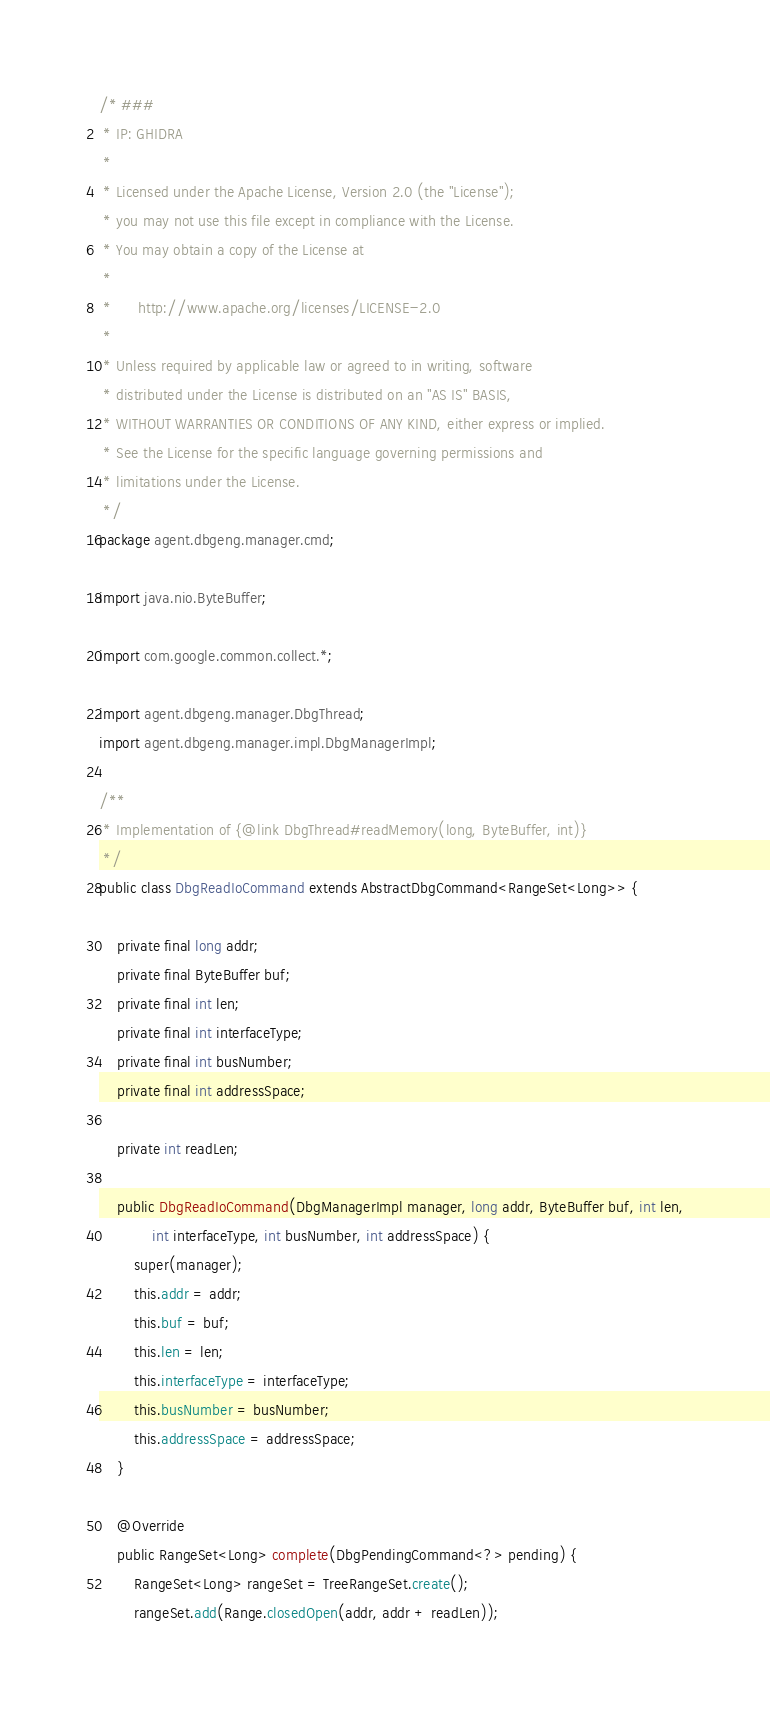Convert code to text. <code><loc_0><loc_0><loc_500><loc_500><_Java_>/* ###
 * IP: GHIDRA
 *
 * Licensed under the Apache License, Version 2.0 (the "License");
 * you may not use this file except in compliance with the License.
 * You may obtain a copy of the License at
 * 
 *      http://www.apache.org/licenses/LICENSE-2.0
 * 
 * Unless required by applicable law or agreed to in writing, software
 * distributed under the License is distributed on an "AS IS" BASIS,
 * WITHOUT WARRANTIES OR CONDITIONS OF ANY KIND, either express or implied.
 * See the License for the specific language governing permissions and
 * limitations under the License.
 */
package agent.dbgeng.manager.cmd;

import java.nio.ByteBuffer;

import com.google.common.collect.*;

import agent.dbgeng.manager.DbgThread;
import agent.dbgeng.manager.impl.DbgManagerImpl;

/**
 * Implementation of {@link DbgThread#readMemory(long, ByteBuffer, int)}
 */
public class DbgReadIoCommand extends AbstractDbgCommand<RangeSet<Long>> {

	private final long addr;
	private final ByteBuffer buf;
	private final int len;
	private final int interfaceType;
	private final int busNumber;
	private final int addressSpace;

	private int readLen;

	public DbgReadIoCommand(DbgManagerImpl manager, long addr, ByteBuffer buf, int len,
			int interfaceType, int busNumber, int addressSpace) {
		super(manager);
		this.addr = addr;
		this.buf = buf;
		this.len = len;
		this.interfaceType = interfaceType;
		this.busNumber = busNumber;
		this.addressSpace = addressSpace;
	}

	@Override
	public RangeSet<Long> complete(DbgPendingCommand<?> pending) {
		RangeSet<Long> rangeSet = TreeRangeSet.create();
		rangeSet.add(Range.closedOpen(addr, addr + readLen));</code> 